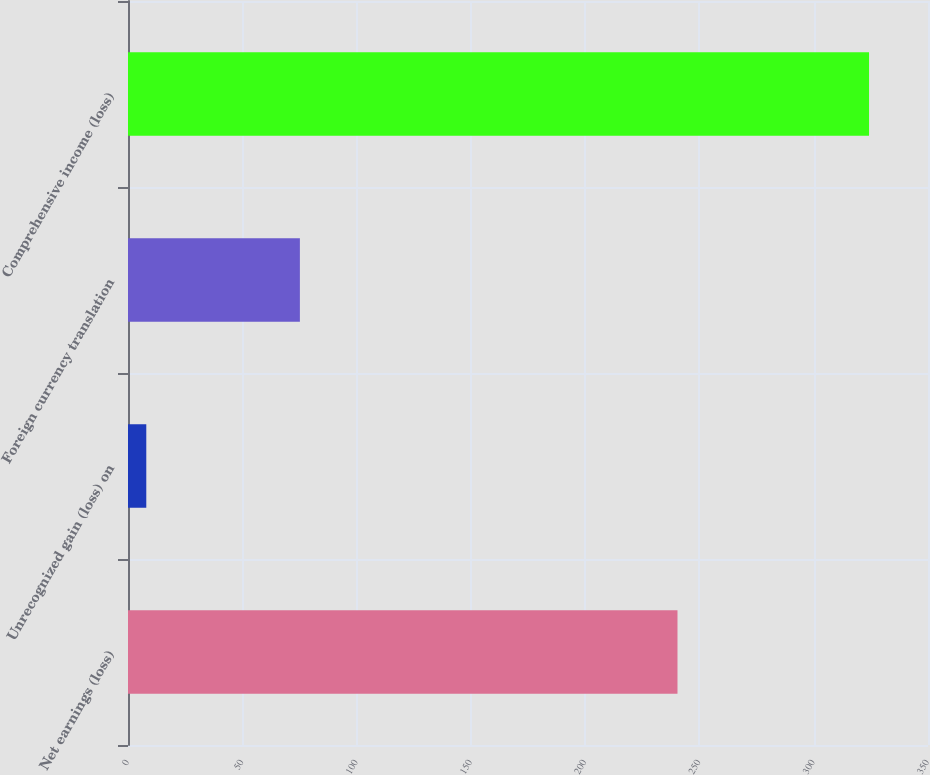Convert chart. <chart><loc_0><loc_0><loc_500><loc_500><bar_chart><fcel>Net earnings (loss)<fcel>Unrecognized gain (loss) on<fcel>Foreign currency translation<fcel>Comprehensive income (loss)<nl><fcel>240.4<fcel>8<fcel>75.2<fcel>324.2<nl></chart> 